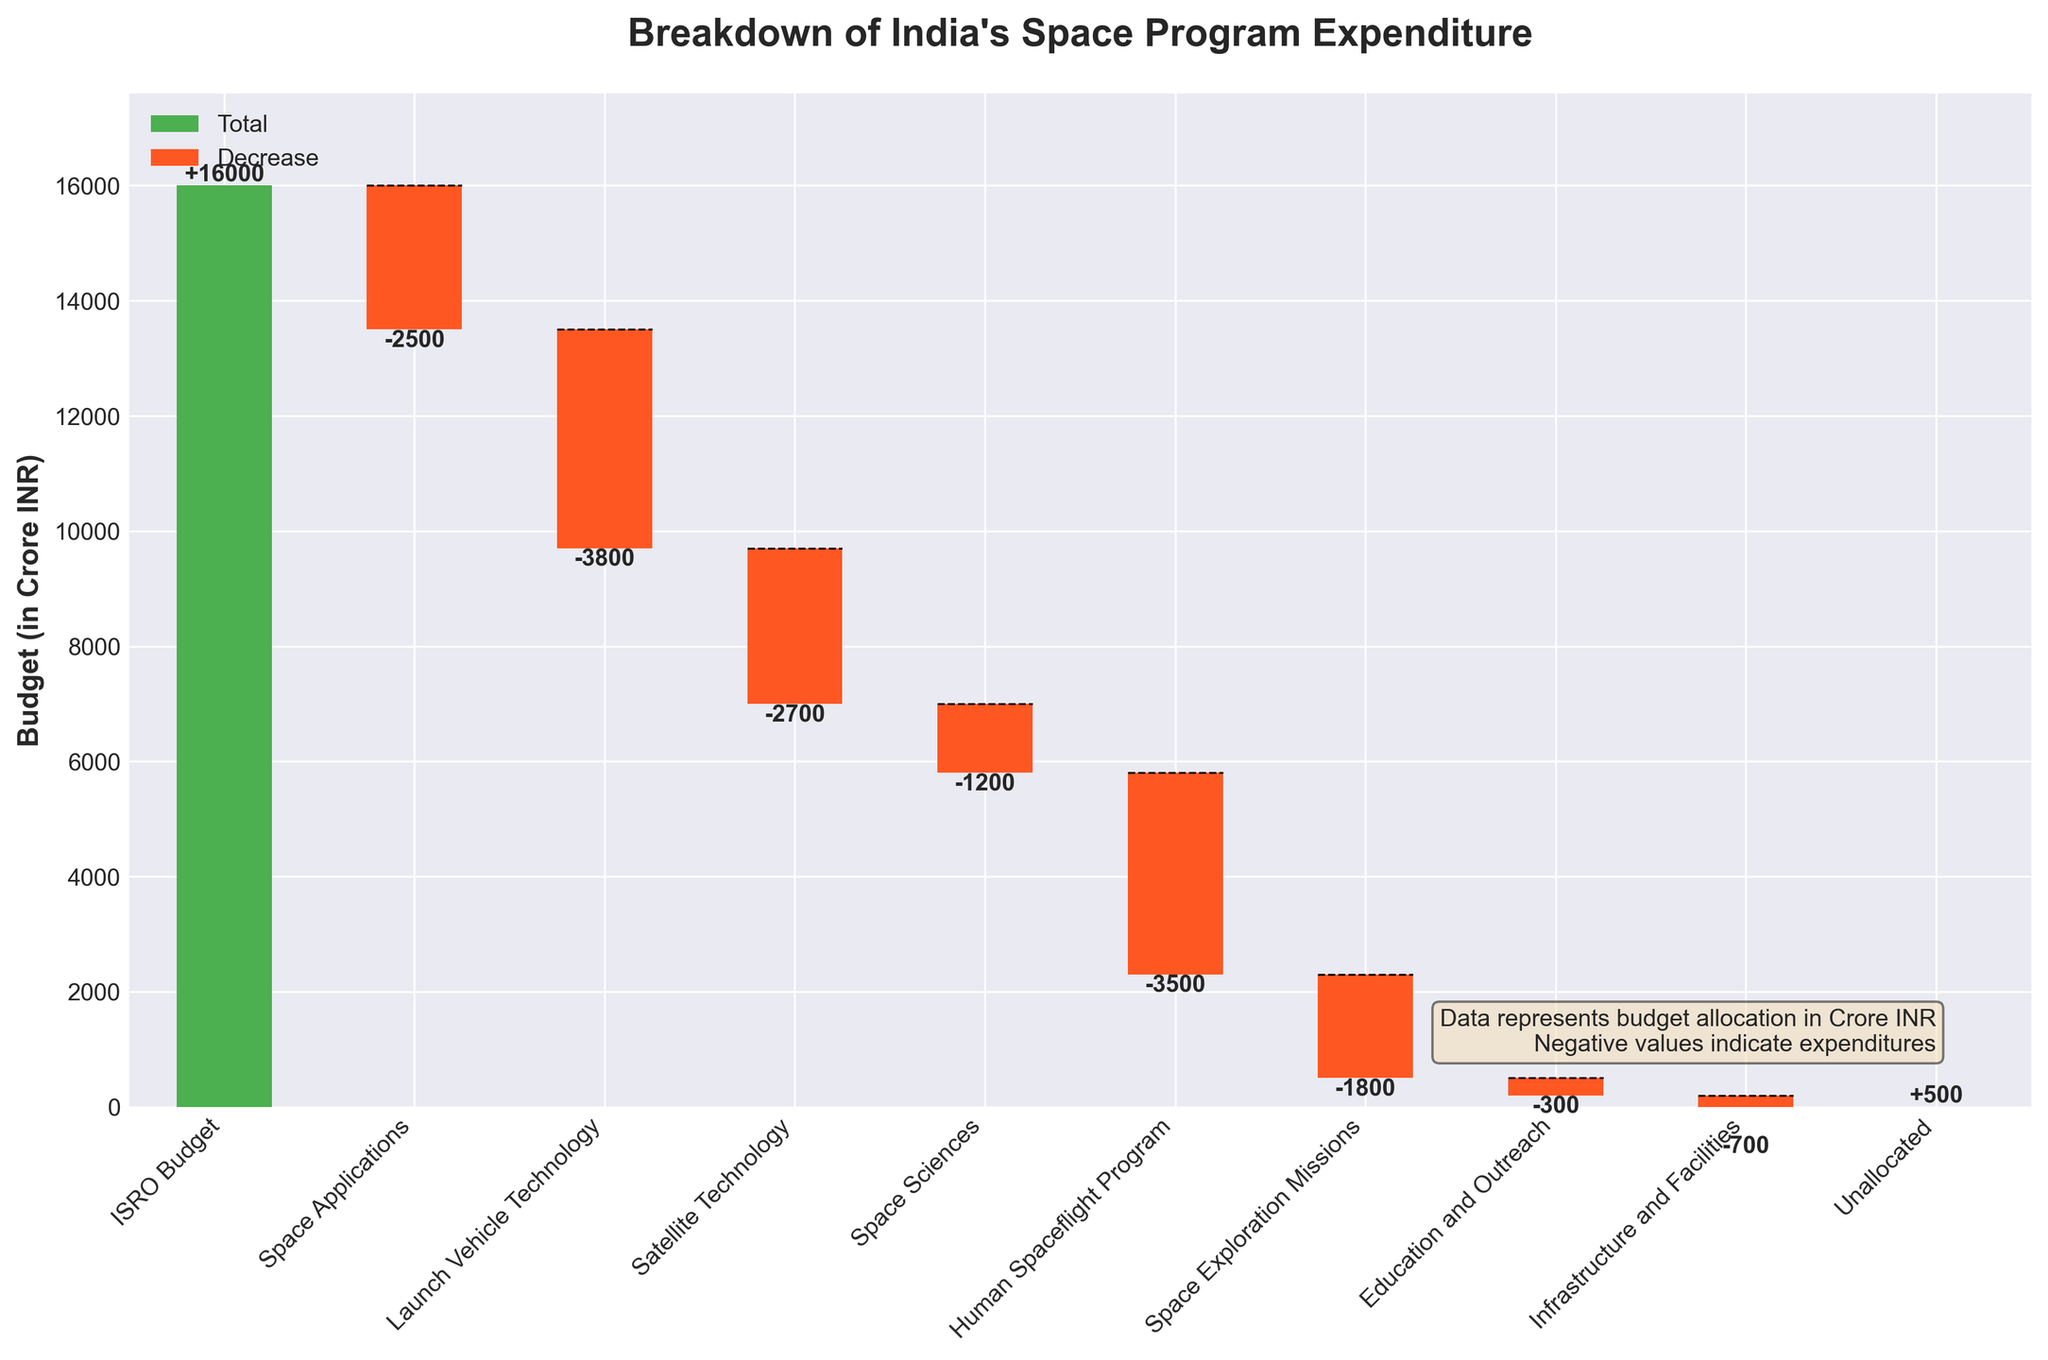Which category has the highest expenditure in India's space program? The highest expenditure in India's space program is represented by the category with the largest negative value. By looking at the chart, the "Launch Vehicle Technology" has the highest negative value at -3800 crore INR.
Answer: Launch Vehicle Technology How much is allocated to the Human Spaceflight Program? To find out the allocation, refer to the value for the "Human Spaceflight Program." The chart indicates a value of -3500 crore INR.
Answer: -3500 crore INR What is the total allocated to Space Applications and Space Exploration Missions combined? Adding the expenditure for "Space Applications" (-2500) to "Space Exploration Missions" (-1800) gives -2500 + (-1800) = -4300 crore INR.
Answer: -4300 crore INR Which categories have positive values, indicating an increase? The categories with positive values are those bars that go up from the previous cumulative total. "ISRO Budget" has a positive value of 16000 crore INR, and "Unallocated" has a positive value of 500 crore INR.
Answer: ISRO Budget, Unallocated How much was allocated to satellite technology? Referring to the value designated to "Satellite Technology," the chart indicates an expenditure of -2700 crore INR.
Answer: -2700 crore INR What is the difference between the allocations for Space Sciences and Education and Outreach? The values for "Space Sciences" and "Education and Outreach" are -1200 and -300 respectively. Their difference is -1200 - (-300) = -900 crore INR.
Answer: -900 crore INR What is the cumulative expenditure after allocating the budget for Space Applications? The initial ISRO Budget is 16000. After Space Applications, which is -2500, the cumulative sum becomes 16000 + (-2500) = 13500 crore INR.
Answer: 13500 crore INR Which category follows Launch Vehicle Technology in terms of expenditure size? By comparing the negative values, the second largest expenditure follows "Launch Vehicle Technology" is "Human Spaceflight Program" with a value of -3500 crore INR.
Answer: Human Spaceflight Program What is the combined effect of Infrastructure and Facilities, and Unallocated funds on the overall expenditure? The values are -700 for "Infrastructure and Facilities" and 500 for "Unallocated." Their combined effect is -700 + 500 = -200 crore INR.
Answer: -200 crore INR Which category has the lowest allocation in terms of expenditure? The category with the lowest absolute negative value represents the smallest allocation. "Education and Outreach" has the lowest allocation at -300 crore INR.
Answer: Education and Outreach 